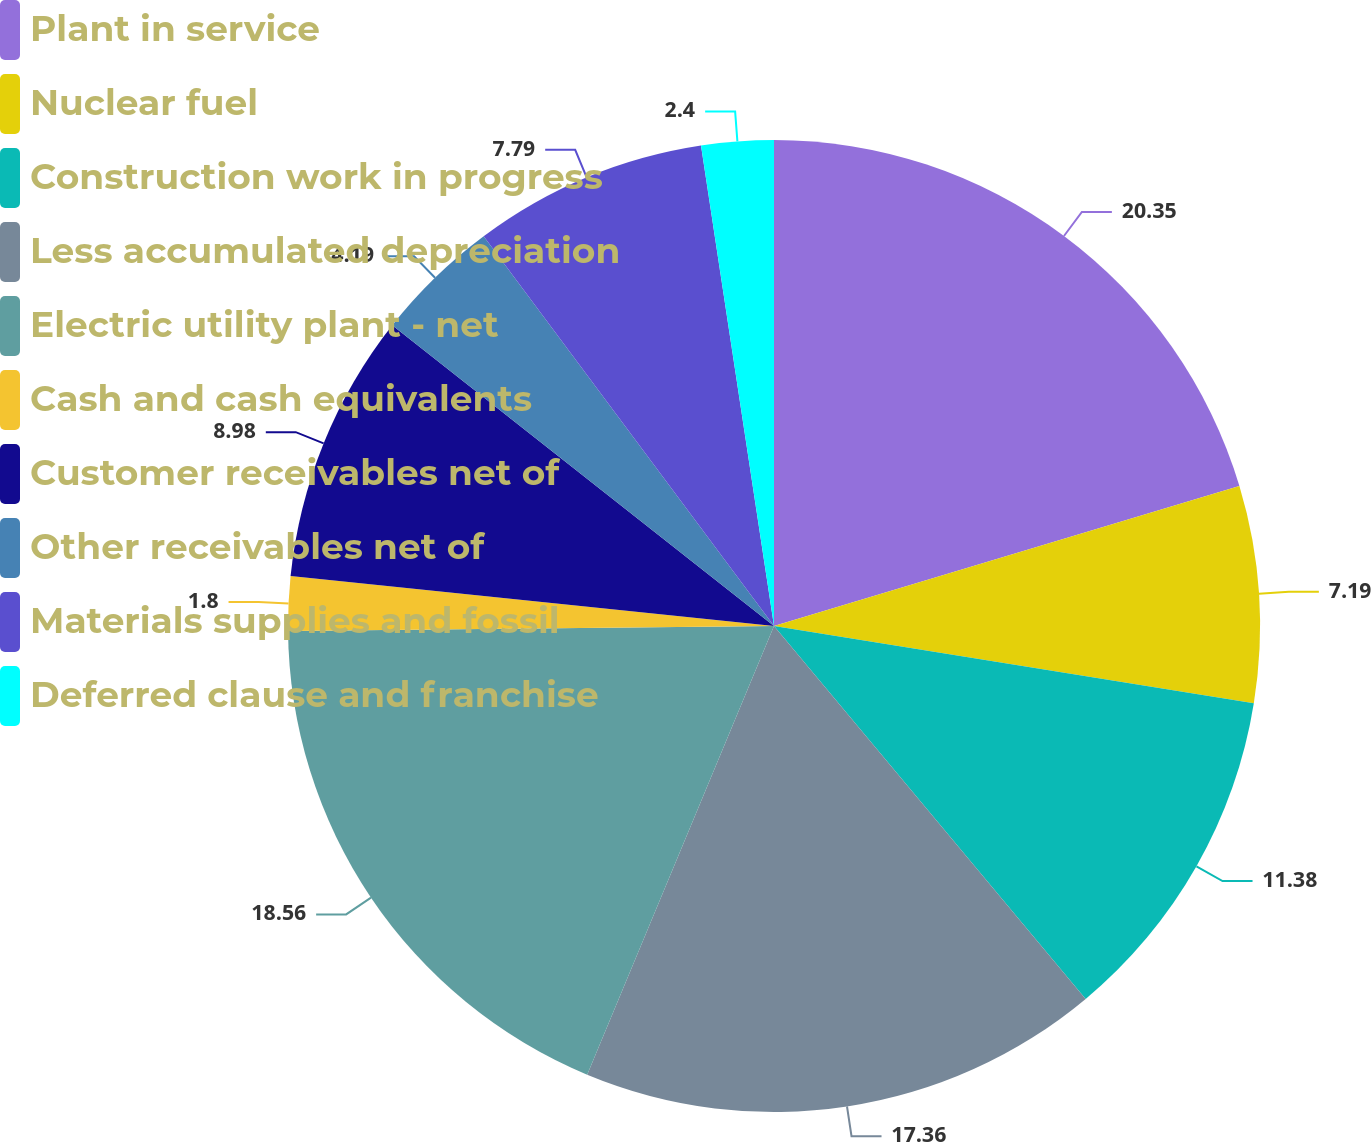<chart> <loc_0><loc_0><loc_500><loc_500><pie_chart><fcel>Plant in service<fcel>Nuclear fuel<fcel>Construction work in progress<fcel>Less accumulated depreciation<fcel>Electric utility plant - net<fcel>Cash and cash equivalents<fcel>Customer receivables net of<fcel>Other receivables net of<fcel>Materials supplies and fossil<fcel>Deferred clause and franchise<nl><fcel>20.35%<fcel>7.19%<fcel>11.38%<fcel>17.36%<fcel>18.56%<fcel>1.8%<fcel>8.98%<fcel>4.19%<fcel>7.79%<fcel>2.4%<nl></chart> 